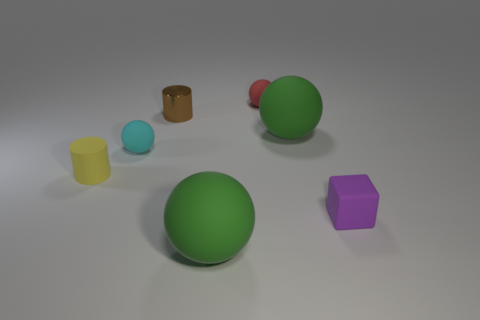Add 1 tiny matte cylinders. How many objects exist? 8 Subtract all cubes. How many objects are left? 6 Subtract all rubber objects. Subtract all cyan rubber cylinders. How many objects are left? 1 Add 3 cyan rubber balls. How many cyan rubber balls are left? 4 Add 1 large red balls. How many large red balls exist? 1 Subtract 0 blue balls. How many objects are left? 7 